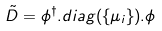Convert formula to latex. <formula><loc_0><loc_0><loc_500><loc_500>\tilde { D } = \phi ^ { \dagger } . d i a g ( \{ \mu _ { i } \} ) . \phi</formula> 